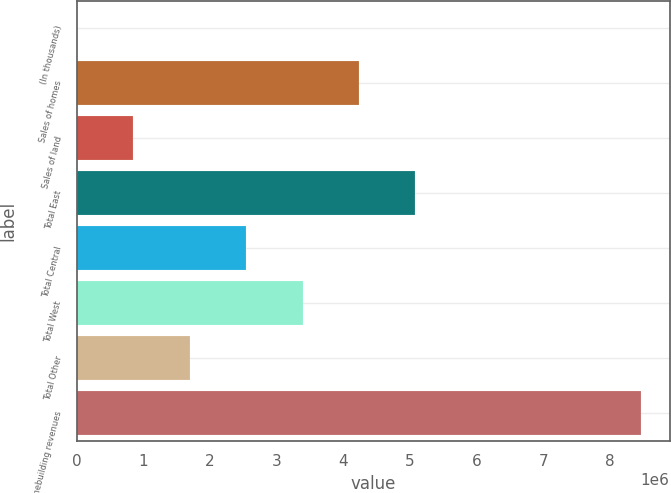Convert chart to OTSL. <chart><loc_0><loc_0><loc_500><loc_500><bar_chart><fcel>(In thousands)<fcel>Sales of homes<fcel>Sales of land<fcel>Total East<fcel>Total Central<fcel>Total West<fcel>Total Other<fcel>Total homebuilding revenues<nl><fcel>2015<fcel>4.23448e+06<fcel>848508<fcel>5.08097e+06<fcel>2.54149e+06<fcel>3.38799e+06<fcel>1.695e+06<fcel>8.46694e+06<nl></chart> 